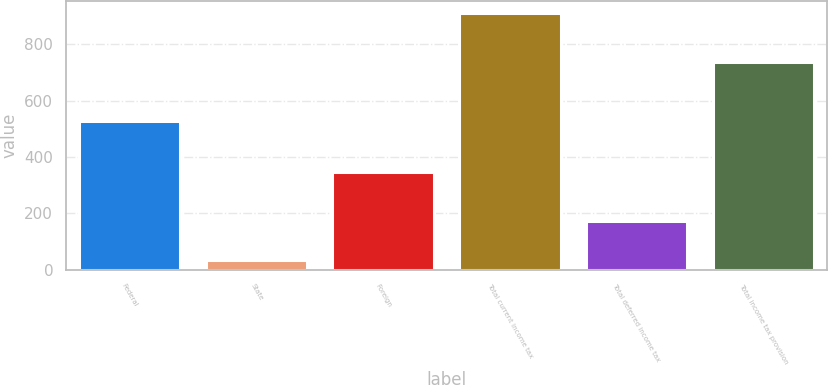<chart> <loc_0><loc_0><loc_500><loc_500><bar_chart><fcel>Federal<fcel>State<fcel>Foreign<fcel>Total current income tax<fcel>Total deferred income tax<fcel>Total income tax provision<nl><fcel>526<fcel>35<fcel>348<fcel>909<fcel>174<fcel>735<nl></chart> 